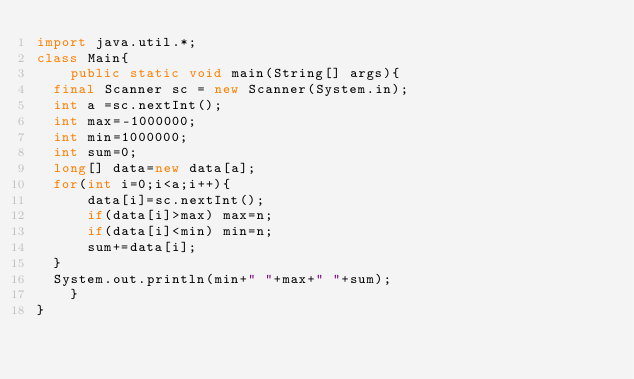Convert code to text. <code><loc_0><loc_0><loc_500><loc_500><_Java_>import java.util.*;
class Main{
    public static void main(String[] args){
	final Scanner sc = new Scanner(System.in);
	int a =sc.nextInt();
	int max=-1000000;
	int min=1000000;
	int sum=0;
	long[] data=new data[a];
	for(int i=0;i<a;i++){
	    data[i]=sc.nextInt();
	    if(data[i]>max) max=n;
	    if(data[i]<min) min=n;
	    sum+=data[i];
	}
	System.out.println(min+" "+max+" "+sum);
    }
}</code> 